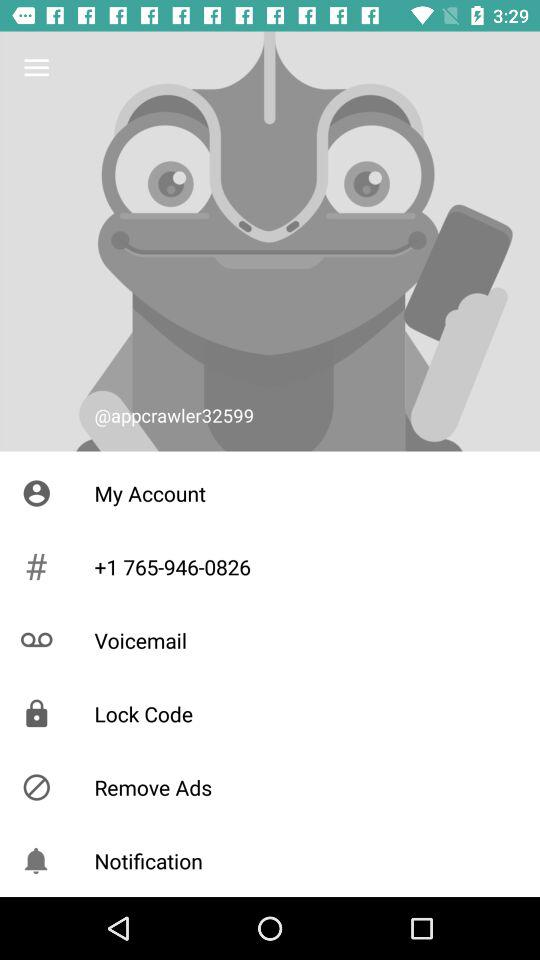How many voicemails do I have?
When the provided information is insufficient, respond with <no answer>. <no answer> 